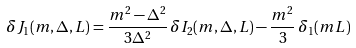Convert formula to latex. <formula><loc_0><loc_0><loc_500><loc_500>\delta J _ { 1 } ( m , \Delta , L ) = \frac { m ^ { 2 } - \Delta ^ { 2 } } { 3 \Delta ^ { 2 } } \, \delta I _ { 2 } ( m , \Delta , L ) - \frac { m ^ { 2 } } { 3 } \, \delta _ { 1 } ( m L )</formula> 